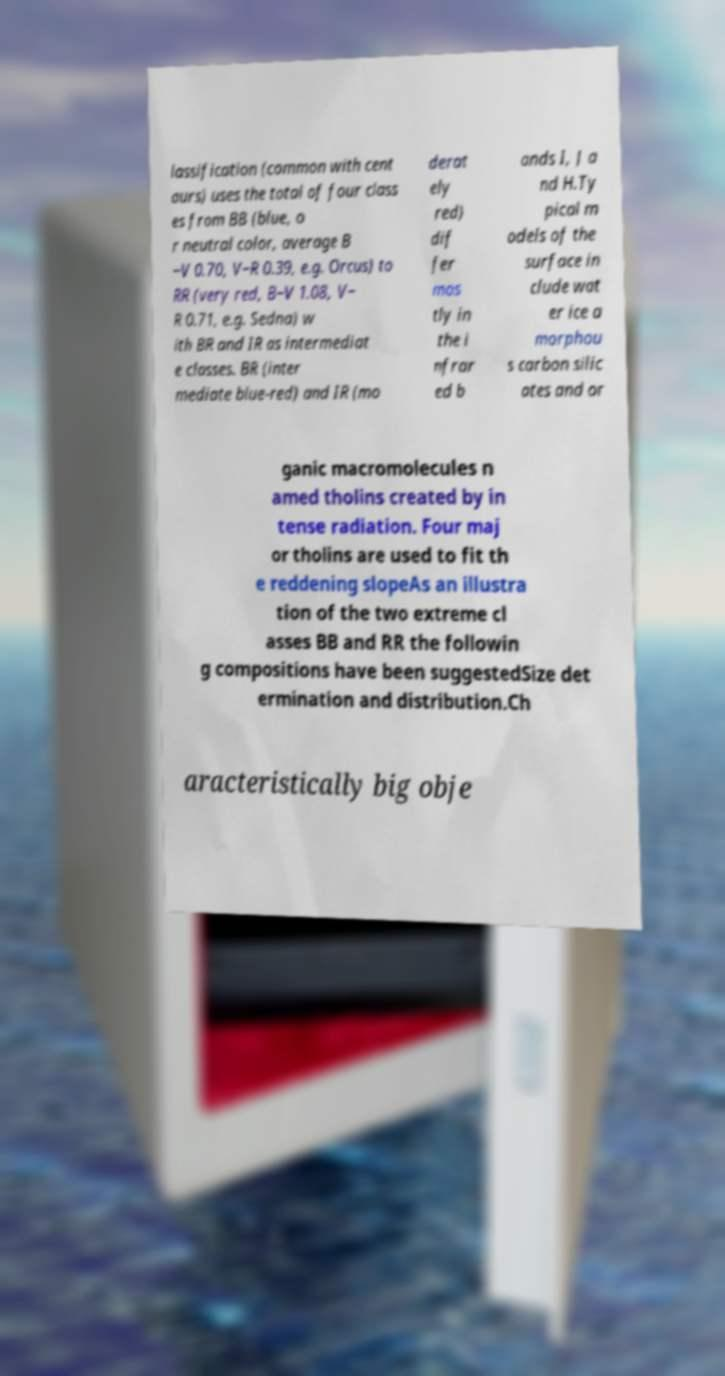Can you read and provide the text displayed in the image?This photo seems to have some interesting text. Can you extract and type it out for me? lassification (common with cent aurs) uses the total of four class es from BB (blue, o r neutral color, average B −V 0.70, V−R 0.39, e.g. Orcus) to RR (very red, B−V 1.08, V− R 0.71, e.g. Sedna) w ith BR and IR as intermediat e classes. BR (inter mediate blue-red) and IR (mo derat ely red) dif fer mos tly in the i nfrar ed b ands I, J a nd H.Ty pical m odels of the surface in clude wat er ice a morphou s carbon silic ates and or ganic macromolecules n amed tholins created by in tense radiation. Four maj or tholins are used to fit th e reddening slopeAs an illustra tion of the two extreme cl asses BB and RR the followin g compositions have been suggestedSize det ermination and distribution.Ch aracteristically big obje 